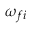<formula> <loc_0><loc_0><loc_500><loc_500>\omega _ { f i }</formula> 